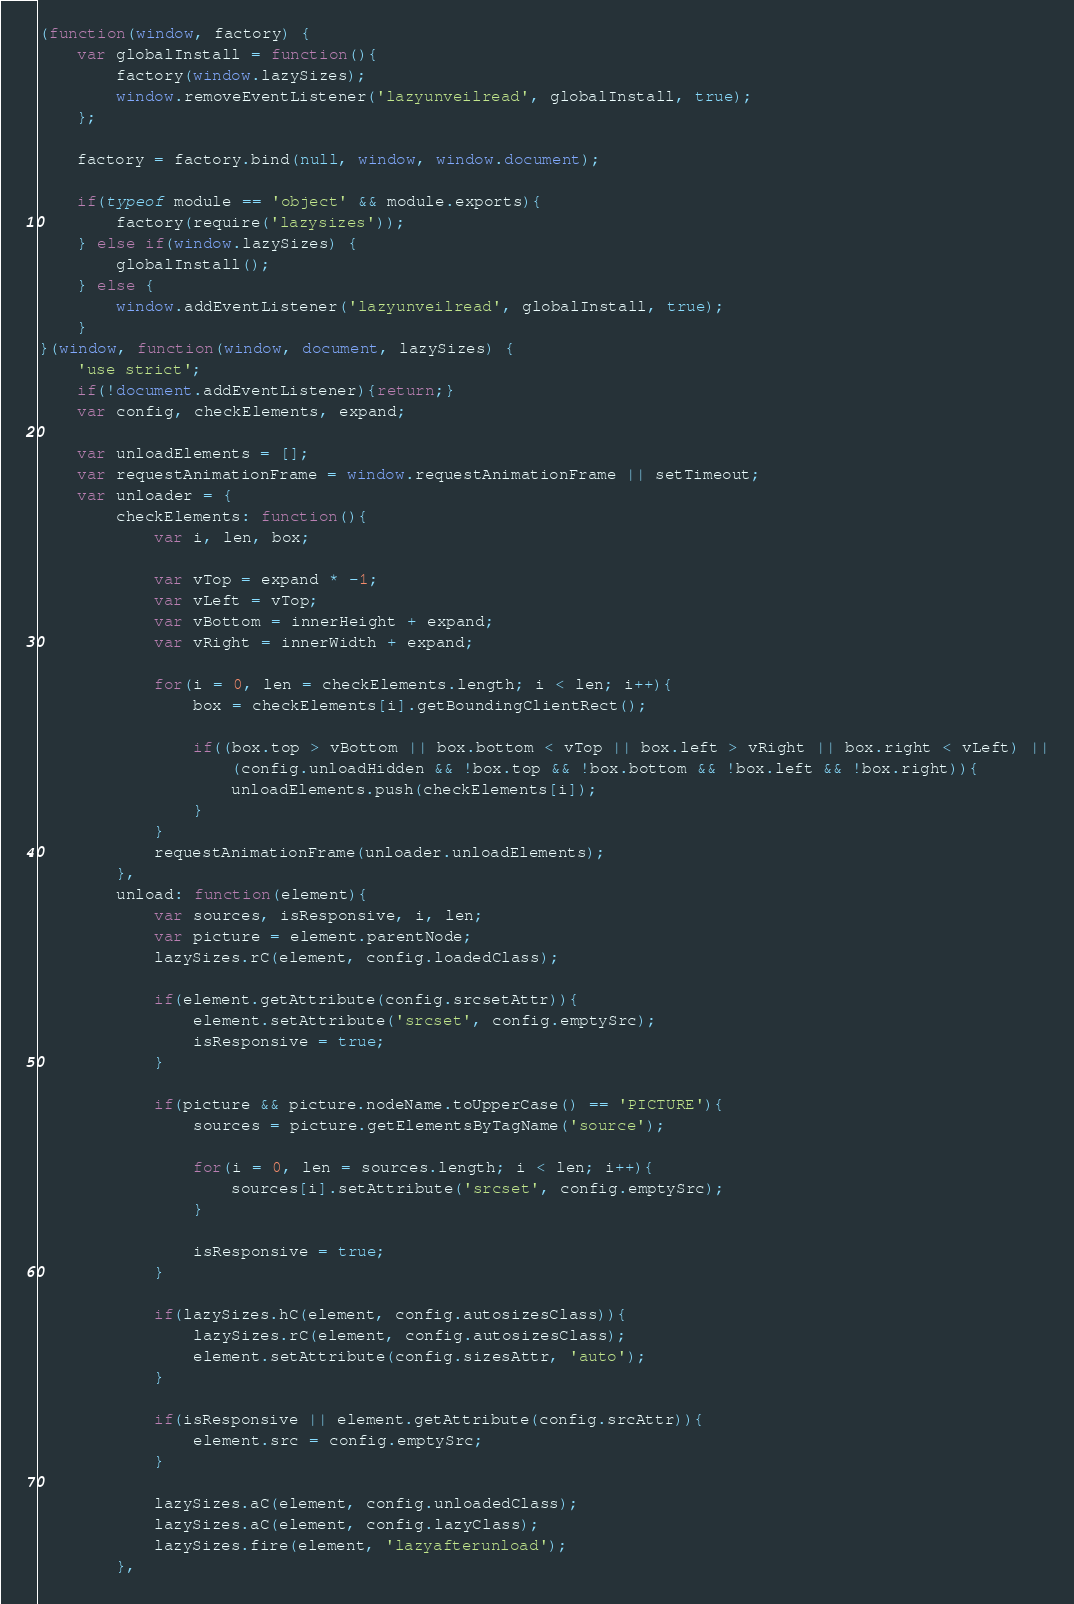Convert code to text. <code><loc_0><loc_0><loc_500><loc_500><_JavaScript_>(function(window, factory) {
	var globalInstall = function(){
		factory(window.lazySizes);
		window.removeEventListener('lazyunveilread', globalInstall, true);
	};

	factory = factory.bind(null, window, window.document);

	if(typeof module == 'object' && module.exports){
		factory(require('lazysizes'));
	} else if(window.lazySizes) {
		globalInstall();
	} else {
		window.addEventListener('lazyunveilread', globalInstall, true);
	}
}(window, function(window, document, lazySizes) {
	'use strict';
	if(!document.addEventListener){return;}
	var config, checkElements, expand;

	var unloadElements = [];
	var requestAnimationFrame = window.requestAnimationFrame || setTimeout;
	var unloader = {
		checkElements: function(){
			var i, len, box;

			var vTop = expand * -1;
			var vLeft = vTop;
			var vBottom = innerHeight + expand;
			var vRight = innerWidth + expand;

			for(i = 0, len = checkElements.length; i < len; i++){
				box = checkElements[i].getBoundingClientRect();

				if((box.top > vBottom || box.bottom < vTop || box.left > vRight || box.right < vLeft) ||
					(config.unloadHidden && !box.top && !box.bottom && !box.left && !box.right)){
					unloadElements.push(checkElements[i]);
				}
			}
			requestAnimationFrame(unloader.unloadElements);
		},
		unload: function(element){
			var sources, isResponsive, i, len;
			var picture = element.parentNode;
			lazySizes.rC(element, config.loadedClass);

			if(element.getAttribute(config.srcsetAttr)){
				element.setAttribute('srcset', config.emptySrc);
				isResponsive = true;
			}

			if(picture && picture.nodeName.toUpperCase() == 'PICTURE'){
				sources = picture.getElementsByTagName('source');

				for(i = 0, len = sources.length; i < len; i++){
					sources[i].setAttribute('srcset', config.emptySrc);
				}

				isResponsive = true;
			}

			if(lazySizes.hC(element, config.autosizesClass)){
				lazySizes.rC(element, config.autosizesClass);
				element.setAttribute(config.sizesAttr, 'auto');
			}

			if(isResponsive || element.getAttribute(config.srcAttr)){
				element.src = config.emptySrc;
			}

			lazySizes.aC(element, config.unloadedClass);
			lazySizes.aC(element, config.lazyClass);
			lazySizes.fire(element, 'lazyafterunload');
		},</code> 